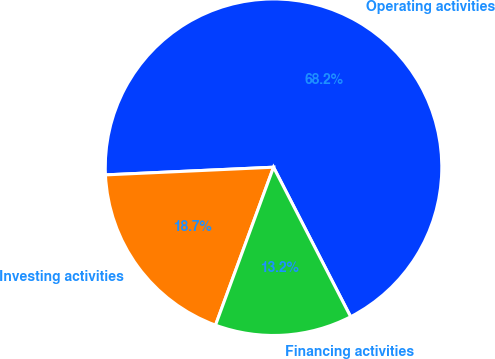Convert chart to OTSL. <chart><loc_0><loc_0><loc_500><loc_500><pie_chart><fcel>Operating activities<fcel>Investing activities<fcel>Financing activities<nl><fcel>68.15%<fcel>18.67%<fcel>13.18%<nl></chart> 